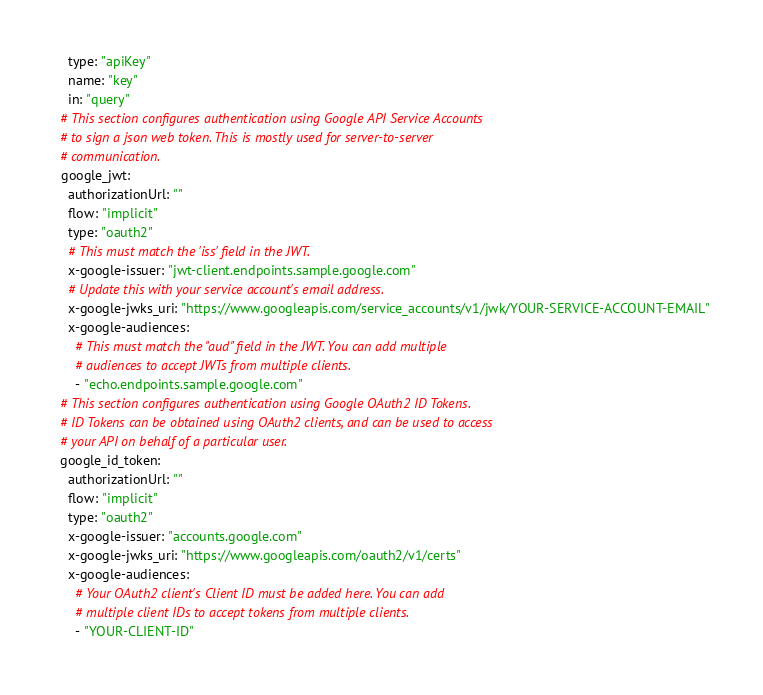<code> <loc_0><loc_0><loc_500><loc_500><_YAML_>    type: "apiKey"
    name: "key"
    in: "query"
  # This section configures authentication using Google API Service Accounts
  # to sign a json web token. This is mostly used for server-to-server
  # communication.
  google_jwt:
    authorizationUrl: ""
    flow: "implicit"
    type: "oauth2"
    # This must match the 'iss' field in the JWT.
    x-google-issuer: "jwt-client.endpoints.sample.google.com"
    # Update this with your service account's email address.
    x-google-jwks_uri: "https://www.googleapis.com/service_accounts/v1/jwk/YOUR-SERVICE-ACCOUNT-EMAIL"
    x-google-audiences:
      # This must match the "aud" field in the JWT. You can add multiple
      # audiences to accept JWTs from multiple clients.
      - "echo.endpoints.sample.google.com"
  # This section configures authentication using Google OAuth2 ID Tokens.
  # ID Tokens can be obtained using OAuth2 clients, and can be used to access
  # your API on behalf of a particular user.
  google_id_token:
    authorizationUrl: ""
    flow: "implicit"
    type: "oauth2"
    x-google-issuer: "accounts.google.com"
    x-google-jwks_uri: "https://www.googleapis.com/oauth2/v1/certs"
    x-google-audiences:
      # Your OAuth2 client's Client ID must be added here. You can add
      # multiple client IDs to accept tokens from multiple clients.
      - "YOUR-CLIENT-ID"
</code> 